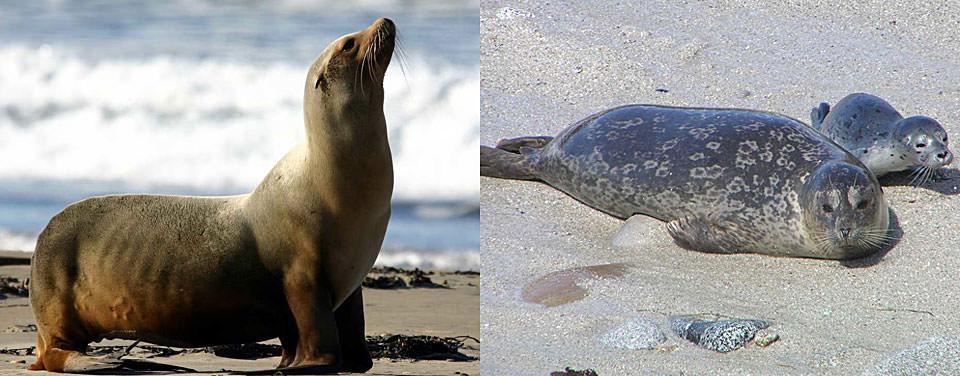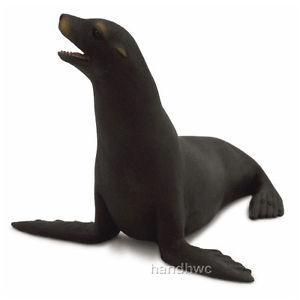The first image is the image on the left, the second image is the image on the right. For the images shown, is this caption "The right image has a plain white background." true? Answer yes or no. Yes. 